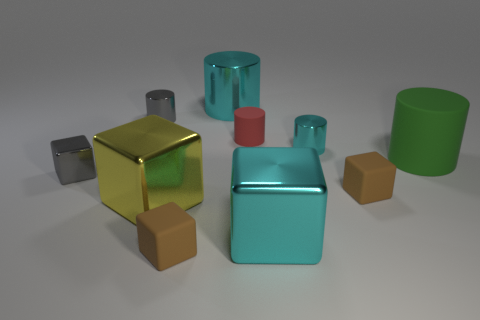Are there more small metal cylinders that are on the right side of the big rubber cylinder than matte cubes behind the tiny cyan thing?
Your response must be concise. No. There is a small brown cube on the right side of the tiny red object; what is its material?
Ensure brevity in your answer.  Rubber. Does the yellow object have the same shape as the matte object on the left side of the big shiny cylinder?
Provide a short and direct response. Yes. There is a small metal thing that is to the right of the shiny cylinder that is left of the large yellow metal block; how many brown rubber blocks are left of it?
Offer a very short reply. 1. There is a tiny rubber thing that is the same shape as the large green object; what color is it?
Your answer should be very brief. Red. Is there any other thing that is the same shape as the yellow shiny thing?
Provide a succinct answer. Yes. What number of balls are either tiny red rubber objects or green objects?
Your response must be concise. 0. The large yellow object is what shape?
Keep it short and to the point. Cube. There is a small matte cylinder; are there any large cyan blocks behind it?
Your response must be concise. No. Is the small red cylinder made of the same material as the big cylinder that is to the right of the tiny cyan thing?
Your response must be concise. Yes. 